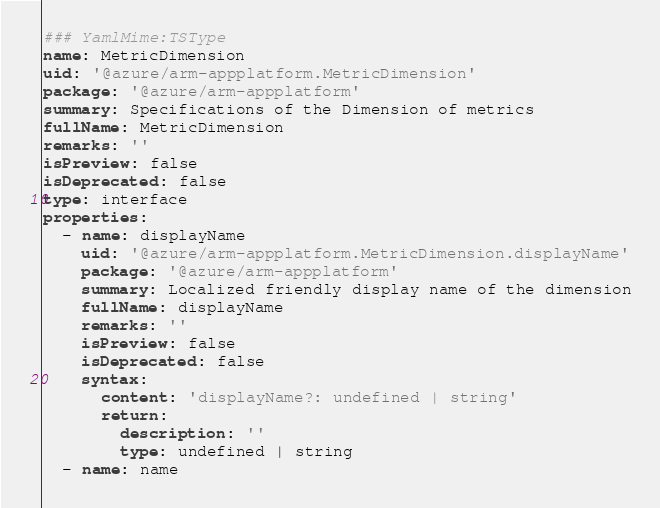<code> <loc_0><loc_0><loc_500><loc_500><_YAML_>### YamlMime:TSType
name: MetricDimension
uid: '@azure/arm-appplatform.MetricDimension'
package: '@azure/arm-appplatform'
summary: Specifications of the Dimension of metrics
fullName: MetricDimension
remarks: ''
isPreview: false
isDeprecated: false
type: interface
properties:
  - name: displayName
    uid: '@azure/arm-appplatform.MetricDimension.displayName'
    package: '@azure/arm-appplatform'
    summary: Localized friendly display name of the dimension
    fullName: displayName
    remarks: ''
    isPreview: false
    isDeprecated: false
    syntax:
      content: 'displayName?: undefined | string'
      return:
        description: ''
        type: undefined | string
  - name: name</code> 